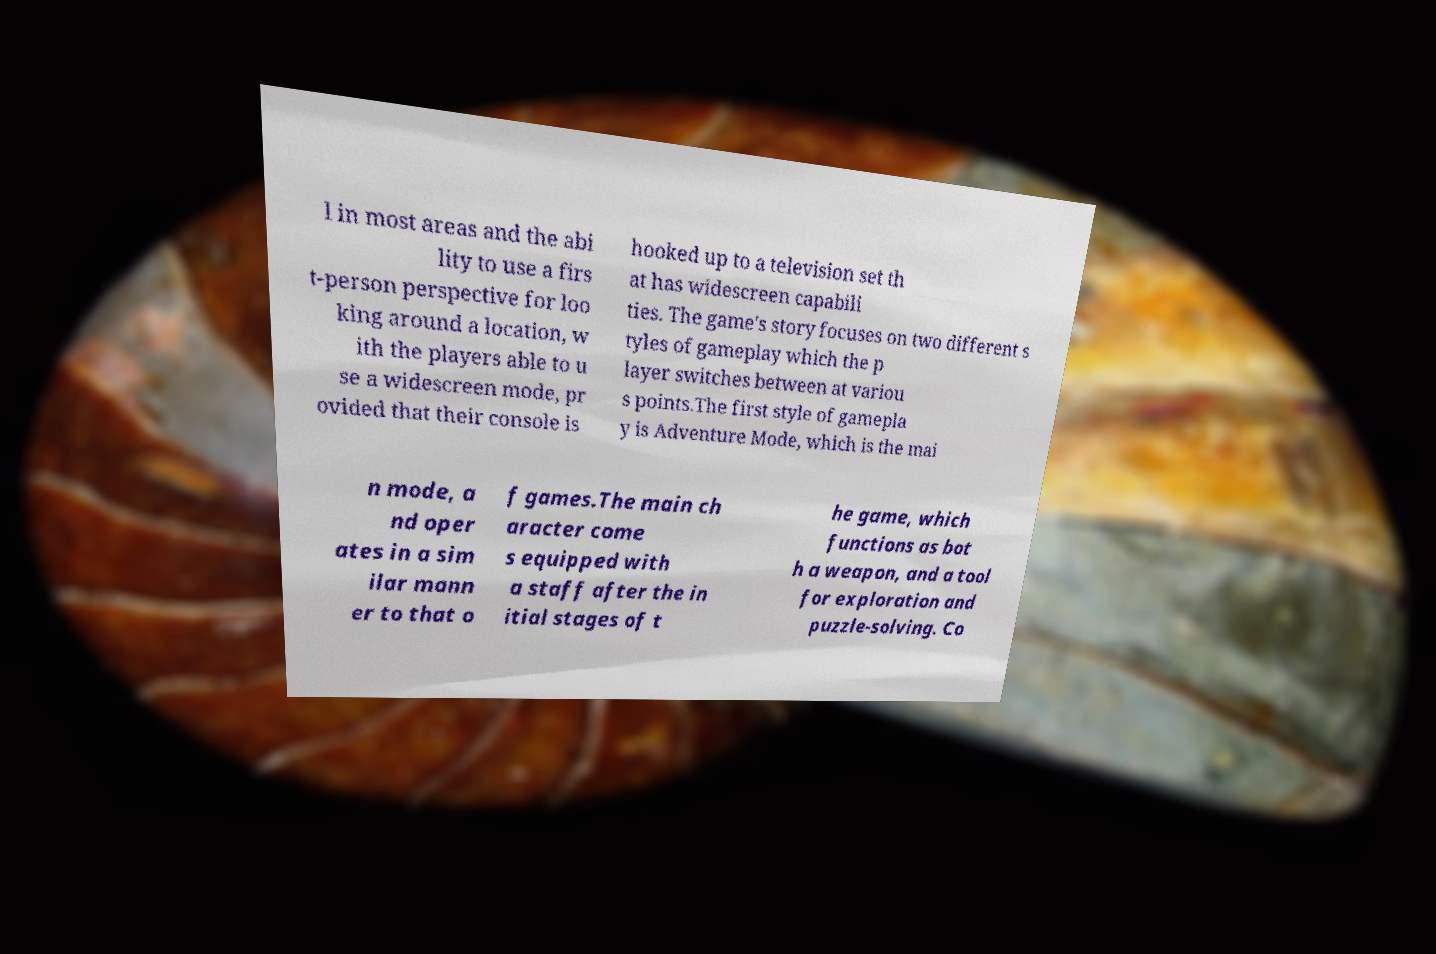What messages or text are displayed in this image? I need them in a readable, typed format. l in most areas and the abi lity to use a firs t-person perspective for loo king around a location, w ith the players able to u se a widescreen mode, pr ovided that their console is hooked up to a television set th at has widescreen capabili ties. The game's story focuses on two different s tyles of gameplay which the p layer switches between at variou s points.The first style of gamepla y is Adventure Mode, which is the mai n mode, a nd oper ates in a sim ilar mann er to that o f games.The main ch aracter come s equipped with a staff after the in itial stages of t he game, which functions as bot h a weapon, and a tool for exploration and puzzle-solving. Co 